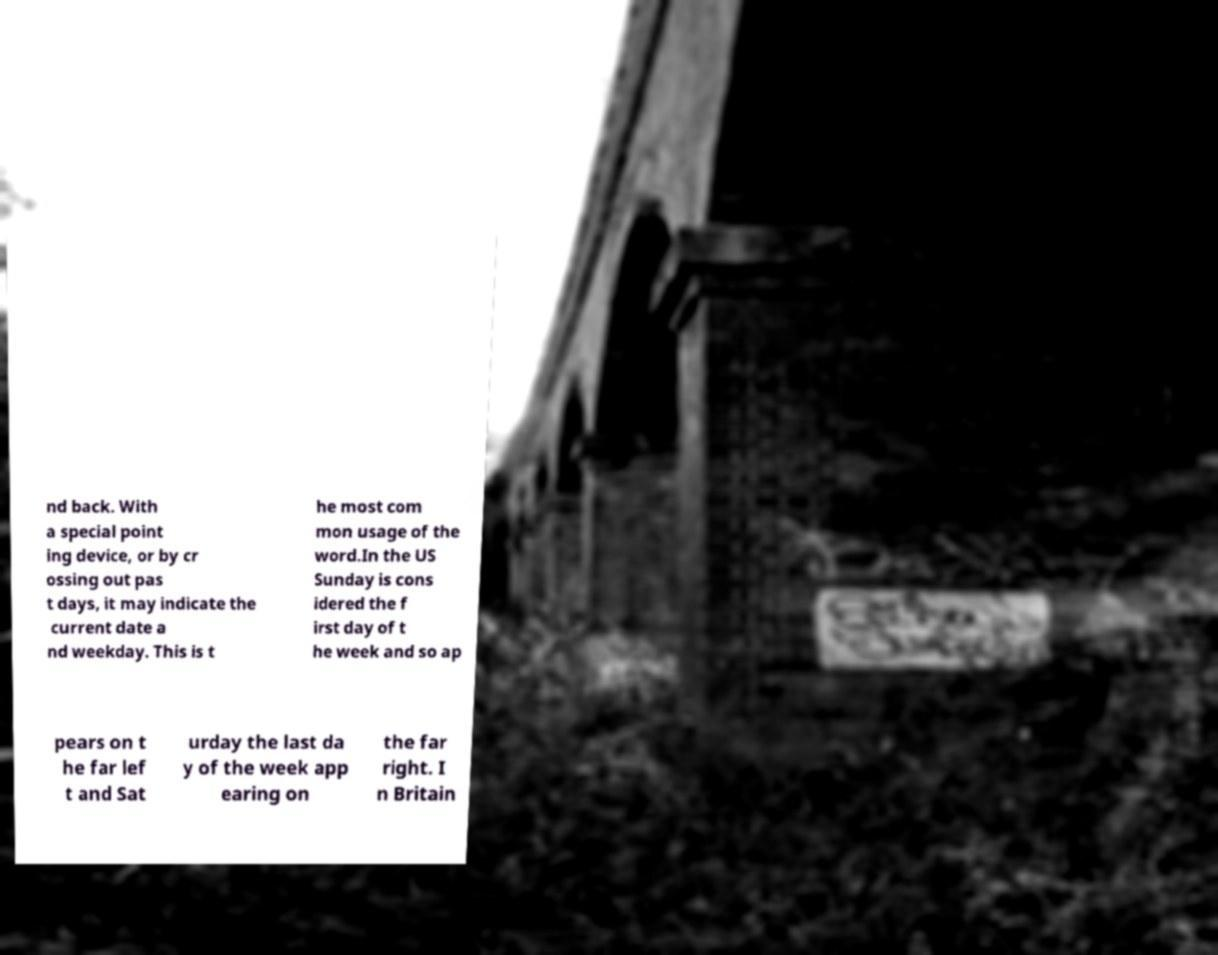There's text embedded in this image that I need extracted. Can you transcribe it verbatim? nd back. With a special point ing device, or by cr ossing out pas t days, it may indicate the current date a nd weekday. This is t he most com mon usage of the word.In the US Sunday is cons idered the f irst day of t he week and so ap pears on t he far lef t and Sat urday the last da y of the week app earing on the far right. I n Britain 